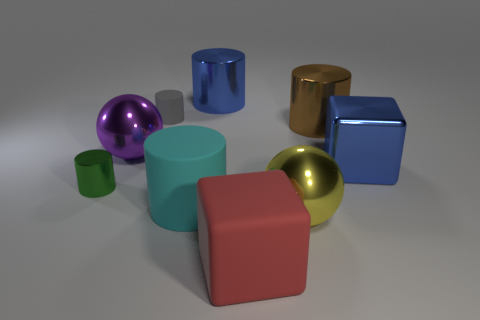What material is the red object in front of the matte cylinder that is in front of the metal ball that is on the left side of the tiny rubber object?
Keep it short and to the point. Rubber. How many other things are there of the same material as the gray cylinder?
Offer a very short reply. 2. There is a ball that is right of the gray thing; what number of large brown metallic things are in front of it?
Your answer should be very brief. 0. How many cylinders are big purple rubber things or big yellow metal things?
Your response must be concise. 0. The cylinder that is both right of the tiny gray object and behind the brown metal cylinder is what color?
Ensure brevity in your answer.  Blue. Is there any other thing of the same color as the big metal cube?
Ensure brevity in your answer.  Yes. There is a metallic cylinder in front of the big metal ball behind the cyan cylinder; what color is it?
Provide a short and direct response. Green. Is the green shiny thing the same size as the red matte cube?
Your answer should be very brief. No. Do the tiny cylinder in front of the big brown thing and the large blue object in front of the purple metallic sphere have the same material?
Make the answer very short. Yes. There is a big blue thing that is in front of the sphere that is to the left of the block in front of the big yellow thing; what is its shape?
Offer a terse response. Cube. 